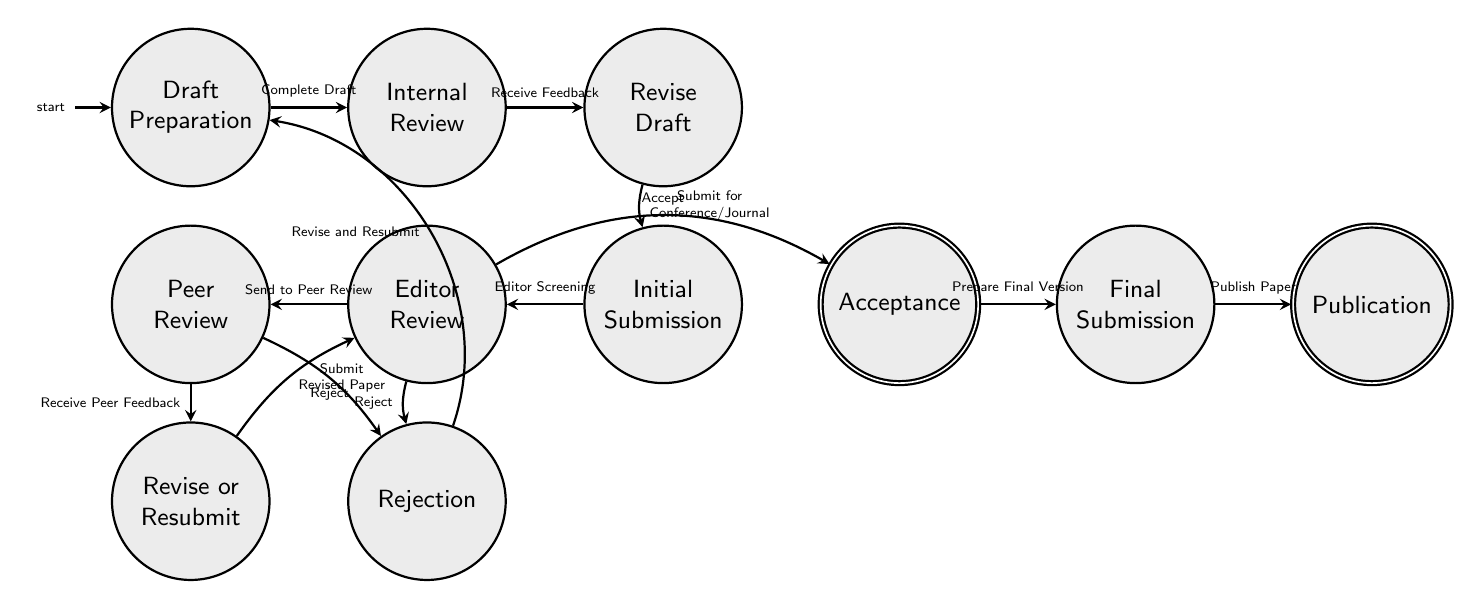What is the first state in the diagram? The first state is the starting point of the flow, which is represented at the top of the diagram. According to the diagram, the first state is entitled "Draft Preparation."
Answer: Draft Preparation How many states are present in the diagram? To determine the number of states, we can visually count each distinct state shown in the diagram. There are ten states listed: Draft Preparation, Internal Review, Revise Draft, Initial Submission, Editor Review, Peer Review, Revise or Resubmit, Acceptance, Rejection, Final Submission, and Publication.
Answer: 10 What action leads from "Internal Review" to "Revise Draft"? The action that connects these two states is labeled on the edge in the diagram. It is explicitly stated as "Receive Feedback." Thus, "Receive Feedback" is the required action for this transition.
Answer: Receive Feedback Which two states are connected by the action "Reject"? According to the diagram, "Reject" connects the state "Editor Review" to the state "Rejection" as well as connects "Peer Review" to "Rejection." Therefore, both pairs are involved with the action "Reject."
Answer: Editor Review and Rejection, Peer Review and Rejection What is the final state after "Final Submission"? The final state represented in the diagram is reached after "Final Submission," where the ultimate output is displayed as "Publication." Thus, the final state is specified in the flow afterward.
Answer: Publication What happens after the state "Rejection"? Based on the diagram, if the paper is rejected, the associated action is "Revise and Resubmit," which leads back to "Draft Preparation." This indicates the process allows for feedback and attempts to resubmit the paper.
Answer: Draft Preparation How many direct transitions are there from "Editor Review"? The transitions are represented as arrows leading from the "Editor Review" state to other states. There are two transitions visible: one to "Peer Review" and another to "Rejection," indicating there are two direct transitions from this state.
Answer: 2 What is the action that leads from "Acceptance" to "Final Submission"? The distinct action connecting "Acceptance" to "Final Submission" is shown as "Prepare Final Version" in the diagram, highlighting the necessary step to progress to the final submission stage.
Answer: Prepare Final Version 